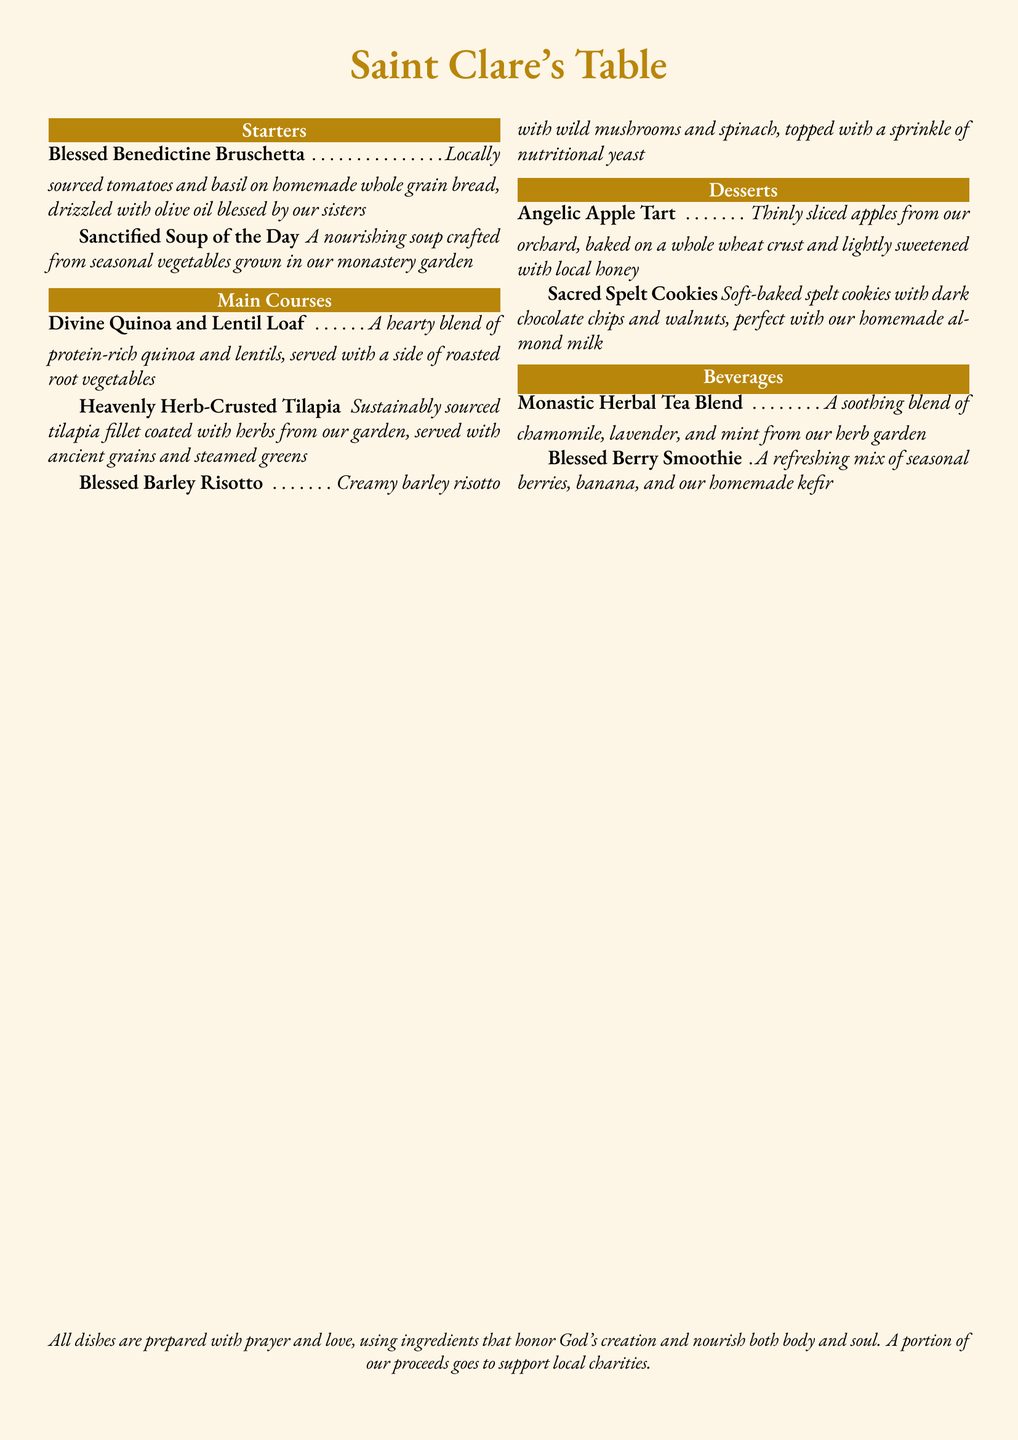What is the name of the restaurant? The title of the menu states the restaurant's name.
Answer: Saint Clare's Table What type of dish is the Blessed Benedictine Bruschetta? The menu categorizes dishes into sections, and this item is listed under starters.
Answer: Starter What ingredients are in the Divine Quinoa and Lentil Loaf? The menu item describes the main components of the dish.
Answer: Quinoa and lentils What kind of fish is used in the Heavenly Herb-Crusted Tilapia? The menu specifically names the fish used in this dish.
Answer: Tilapia How is the Angelic Apple Tart sweetened? The description provides information on how the dessert is sweetened.
Answer: Local honey Which beverage is made with seasonal berries? The menu lists beverages, and this one mentions its main ingredient in the title.
Answer: Blessed Berry Smoothie What is the main grain in the Blessed Barley Risotto? The menu describes the key ingredient used in the risotto.
Answer: Barley How are the Sacred Spelt Cookies served? The description indicates a specific accompaniment for the cookies.
Answer: With homemade almond milk What type of tea is offered in the beverages section? The menu specifies the type of tea offered as a beverage.
Answer: Herbal tea blend What additional purpose do the proceeds of the menu serve? The concluding statement outlines how proceeds from the meals contribute to a cause.
Answer: Support local charities 